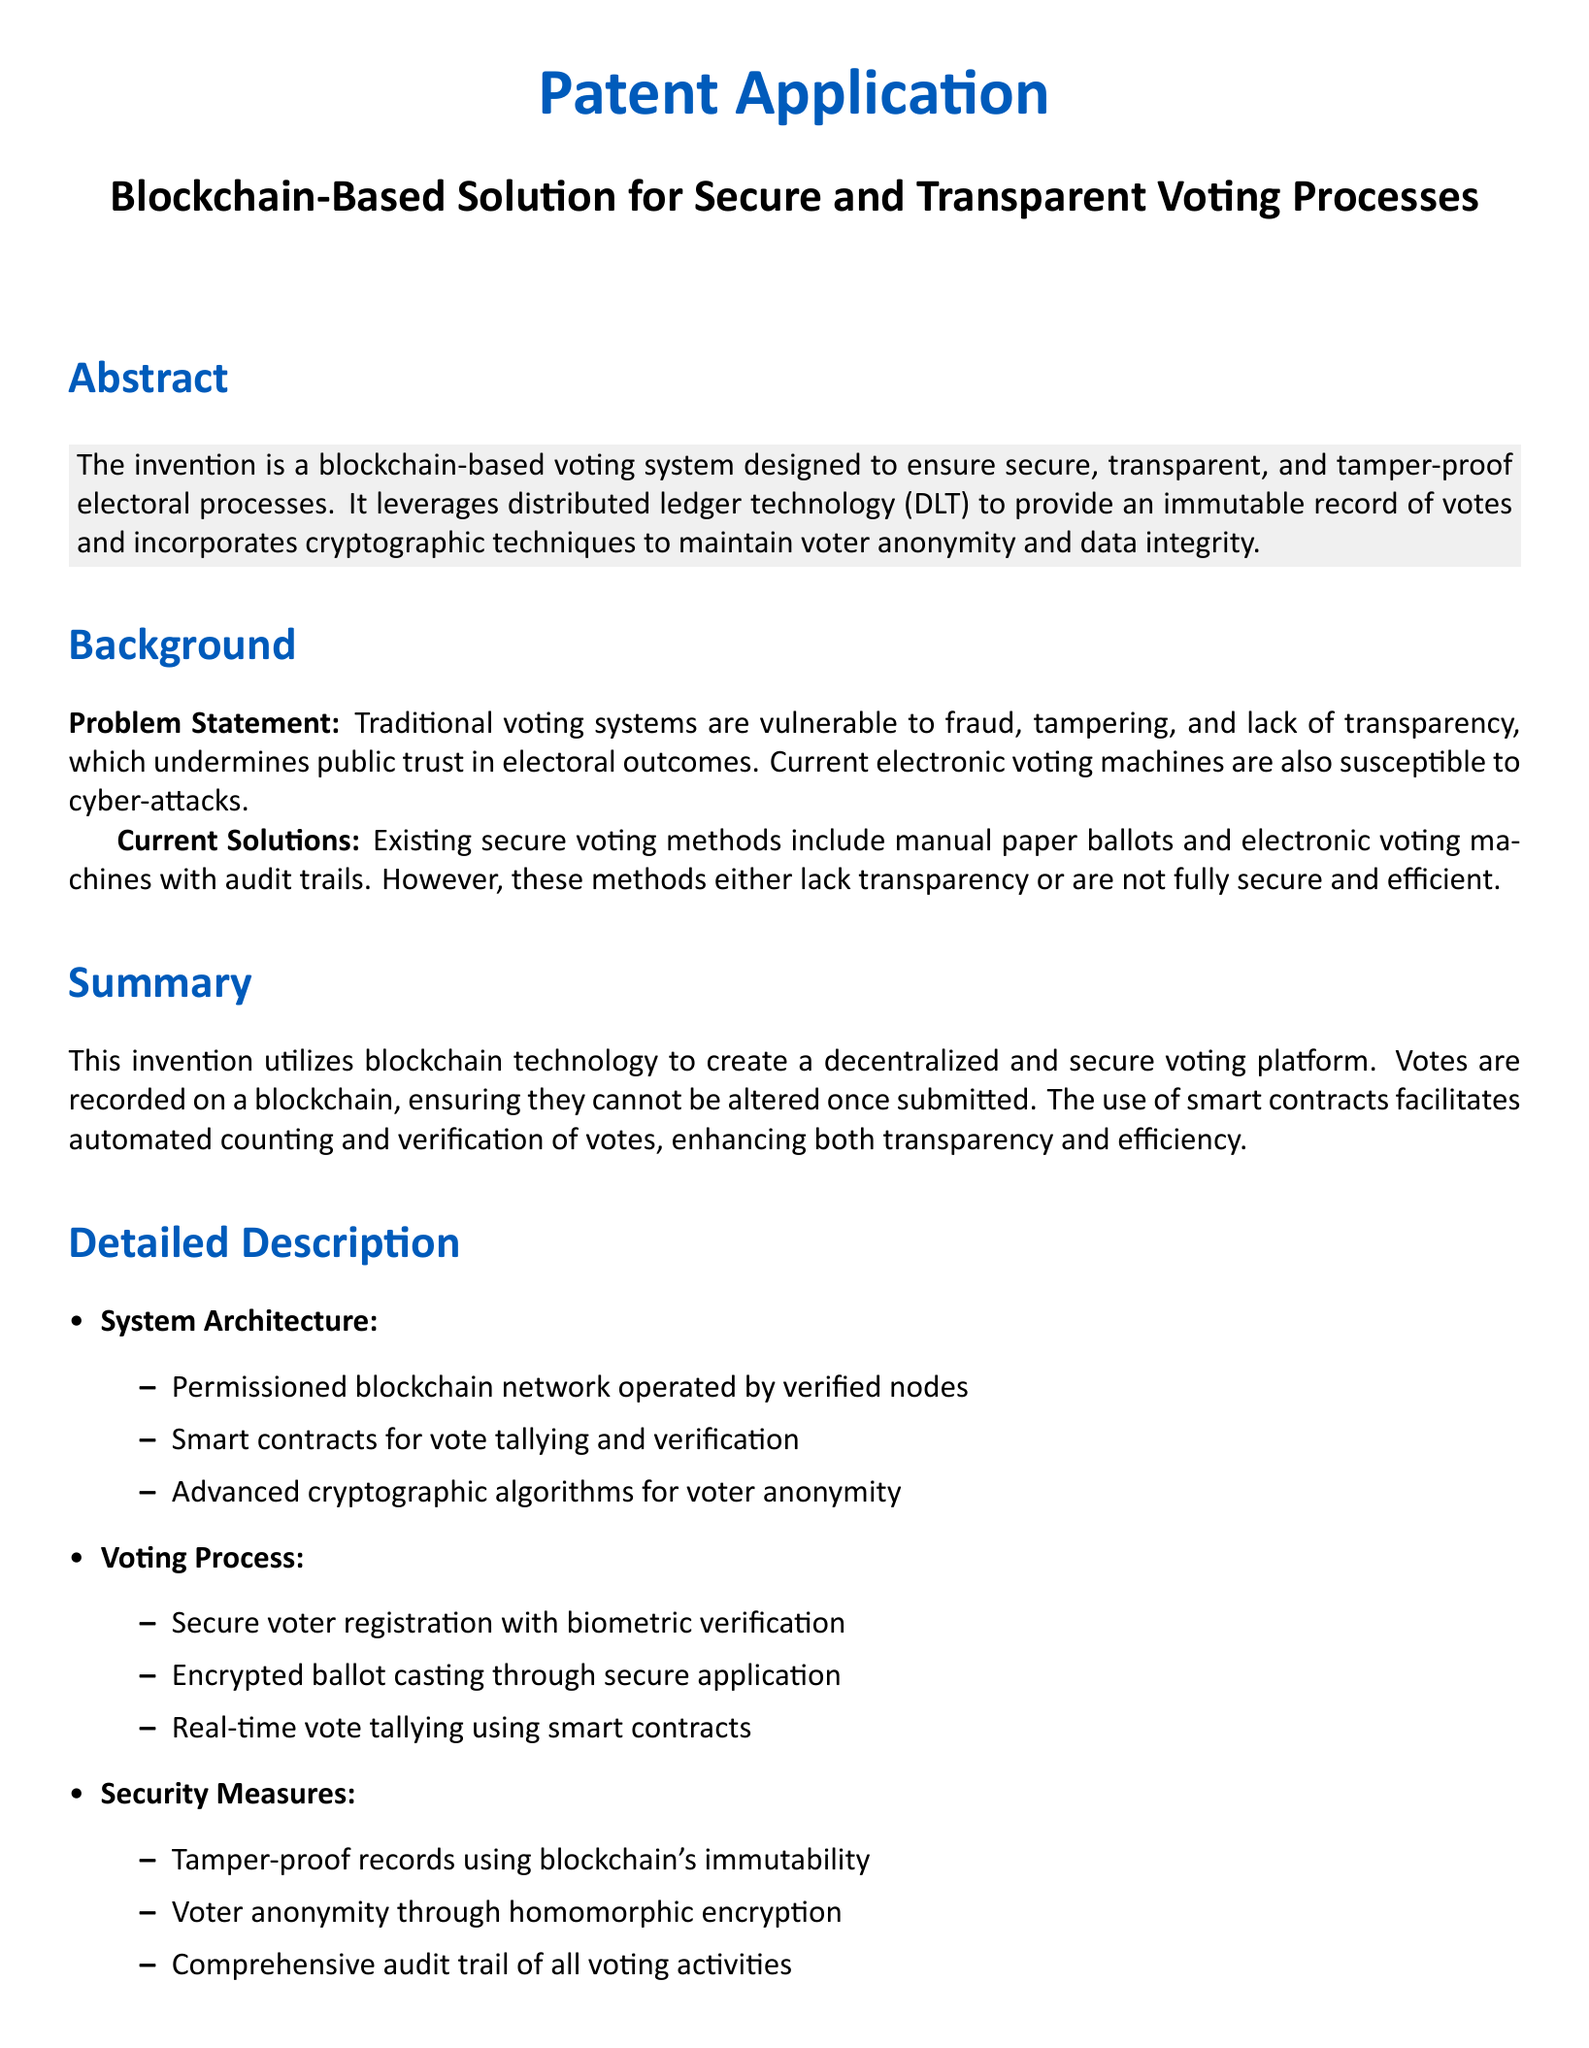What is the purpose of the invention? The invention aims to ensure secure, transparent, and tamper-proof electoral processes through a blockchain-based voting system.
Answer: To ensure secure, transparent, and tamper-proof electoral processes What problem does the invention aim to solve? The problem statement highlights vulnerabilities in traditional voting systems, such as fraud and lack of transparency, which undermine public trust.
Answer: Vulnerabilities in traditional voting systems What are the three current solutions mentioned? The document states that existing secure voting methods include manual paper ballots and electronic voting machines with audit trails.
Answer: Manual paper ballots and electronic voting machines with audit trails What is the role of smart contracts in this system? Smart contracts are utilized for automating the tallying and verification of votes.
Answer: Automating the tallying and verification of votes How many claims are listed in the patent application? The claims section enumerates three distinct claims regarding the voting system's features.
Answer: Three What does the system use for voter anonymity? The document specifies that cryptographic techniques such as homomorphic encryption are utilized to ensure voter anonymity.
Answer: Homomorphic encryption What is one advantage of the proposed voting system? One of the advantages highlighted is enhanced security, which eliminates the risk of vote tampering and ensures data integrity.
Answer: Enhanced security What type of blockchain network is proposed in the system architecture? The proposed architecture features a permissioned blockchain network operated by verified nodes for security purposes.
Answer: Permissioned blockchain network What verification method is mentioned for secure voter registration? The document states that biometric verification is used for secure voter registration.
Answer: Biometric verification 